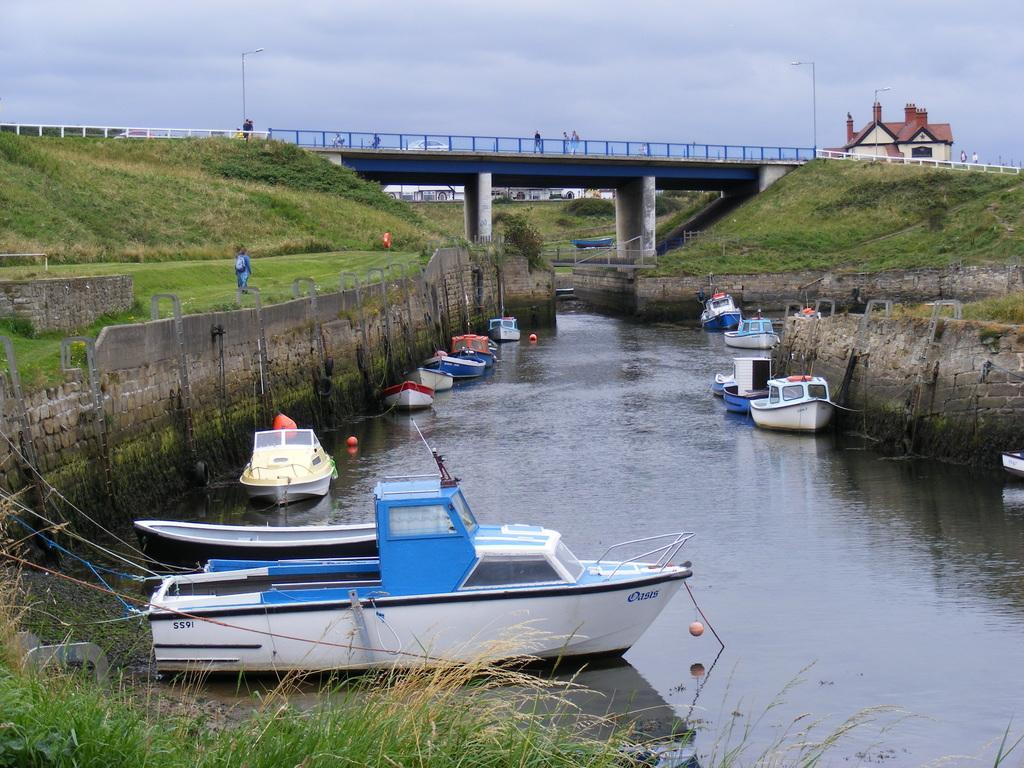Could you give a brief overview of what you see in this image? In this image we can see a lake. To the both side of the lake boats are present and the land is full of grass. In the middle of the image we can see a blue color bridge, poles and one building. The cloud is present. 